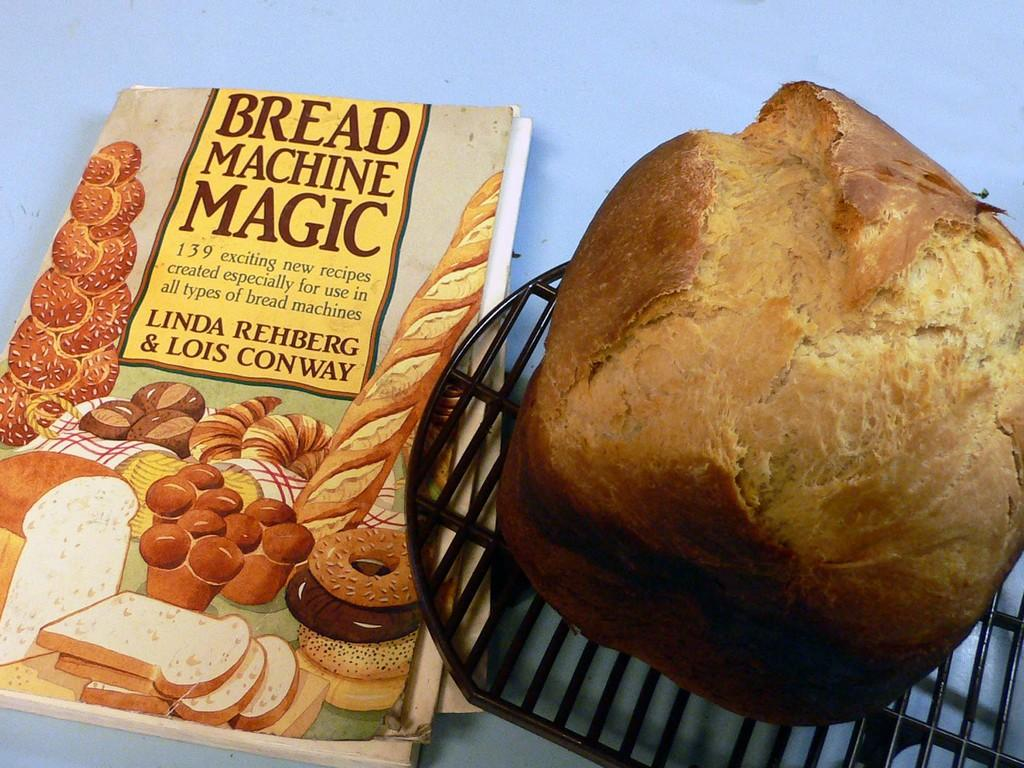What is one of the objects visible in the image? There is a book in the image. What type of food is present in the image? There is bread in the image. What is used to hold the bread? There is a bread holder in the image. Where might the bread holder be located? The bread holder may be on the floor. Can you describe the setting of the image? The image may have been taken in a room. What type of pen can be seen in the image? There is no pen present in the image. What impulse might have caused the error in the image? There is no error present in the image, and therefore no impulse can be identified. 